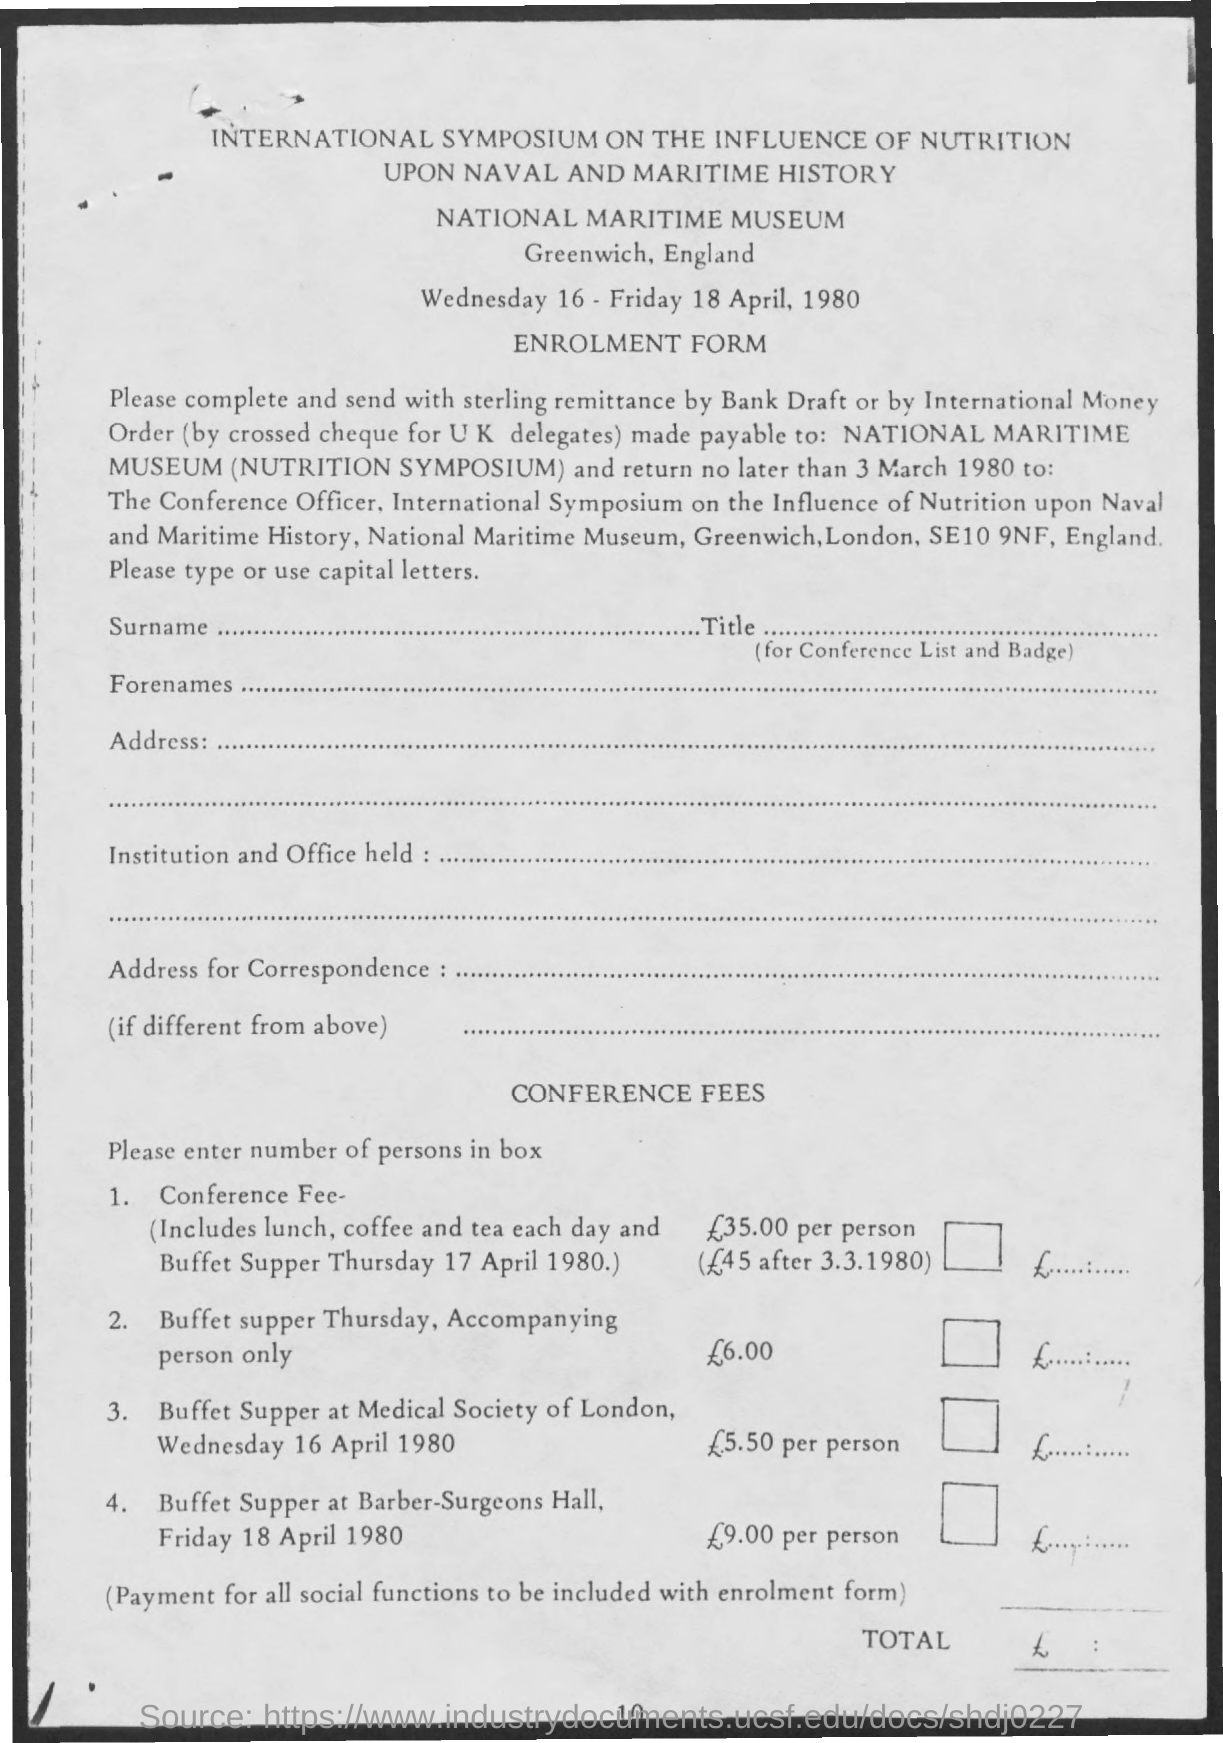What is the Page Number?
Your response must be concise. 10. What is the first title in the document?
Provide a succinct answer. INTERNATIONAL SYMPOSIUM ON THE INFLUENCE OF NUTRITION. What is the name of the form?
Your response must be concise. ENROLMENT FORM. What is the name of the museum?
Make the answer very short. National Maritime Museum. 